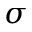Convert formula to latex. <formula><loc_0><loc_0><loc_500><loc_500>\sigma</formula> 